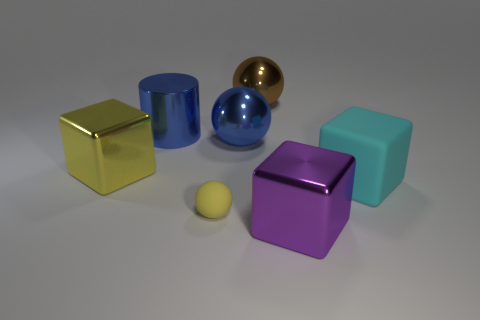Is there anything else that is the same size as the yellow rubber sphere?
Your response must be concise. No. There is a cylinder that is the same material as the big purple block; what is its size?
Provide a short and direct response. Large. How many small gray rubber things are the same shape as the large purple object?
Your response must be concise. 0. There is a big sphere in front of the blue shiny cylinder; does it have the same color as the small sphere?
Give a very brief answer. No. There is a ball left of the large blue thing that is right of the large blue cylinder; how many cubes are on the right side of it?
Offer a very short reply. 2. What number of large objects are both right of the yellow cube and to the left of the matte block?
Your response must be concise. 4. What shape is the large thing that is the same color as the tiny sphere?
Keep it short and to the point. Cube. Is the big brown sphere made of the same material as the blue cylinder?
Ensure brevity in your answer.  Yes. There is a yellow thing in front of the big yellow block in front of the big sphere that is in front of the big blue cylinder; what shape is it?
Offer a terse response. Sphere. Is the number of large brown balls in front of the tiny yellow rubber ball less than the number of rubber things left of the big matte object?
Ensure brevity in your answer.  Yes. 